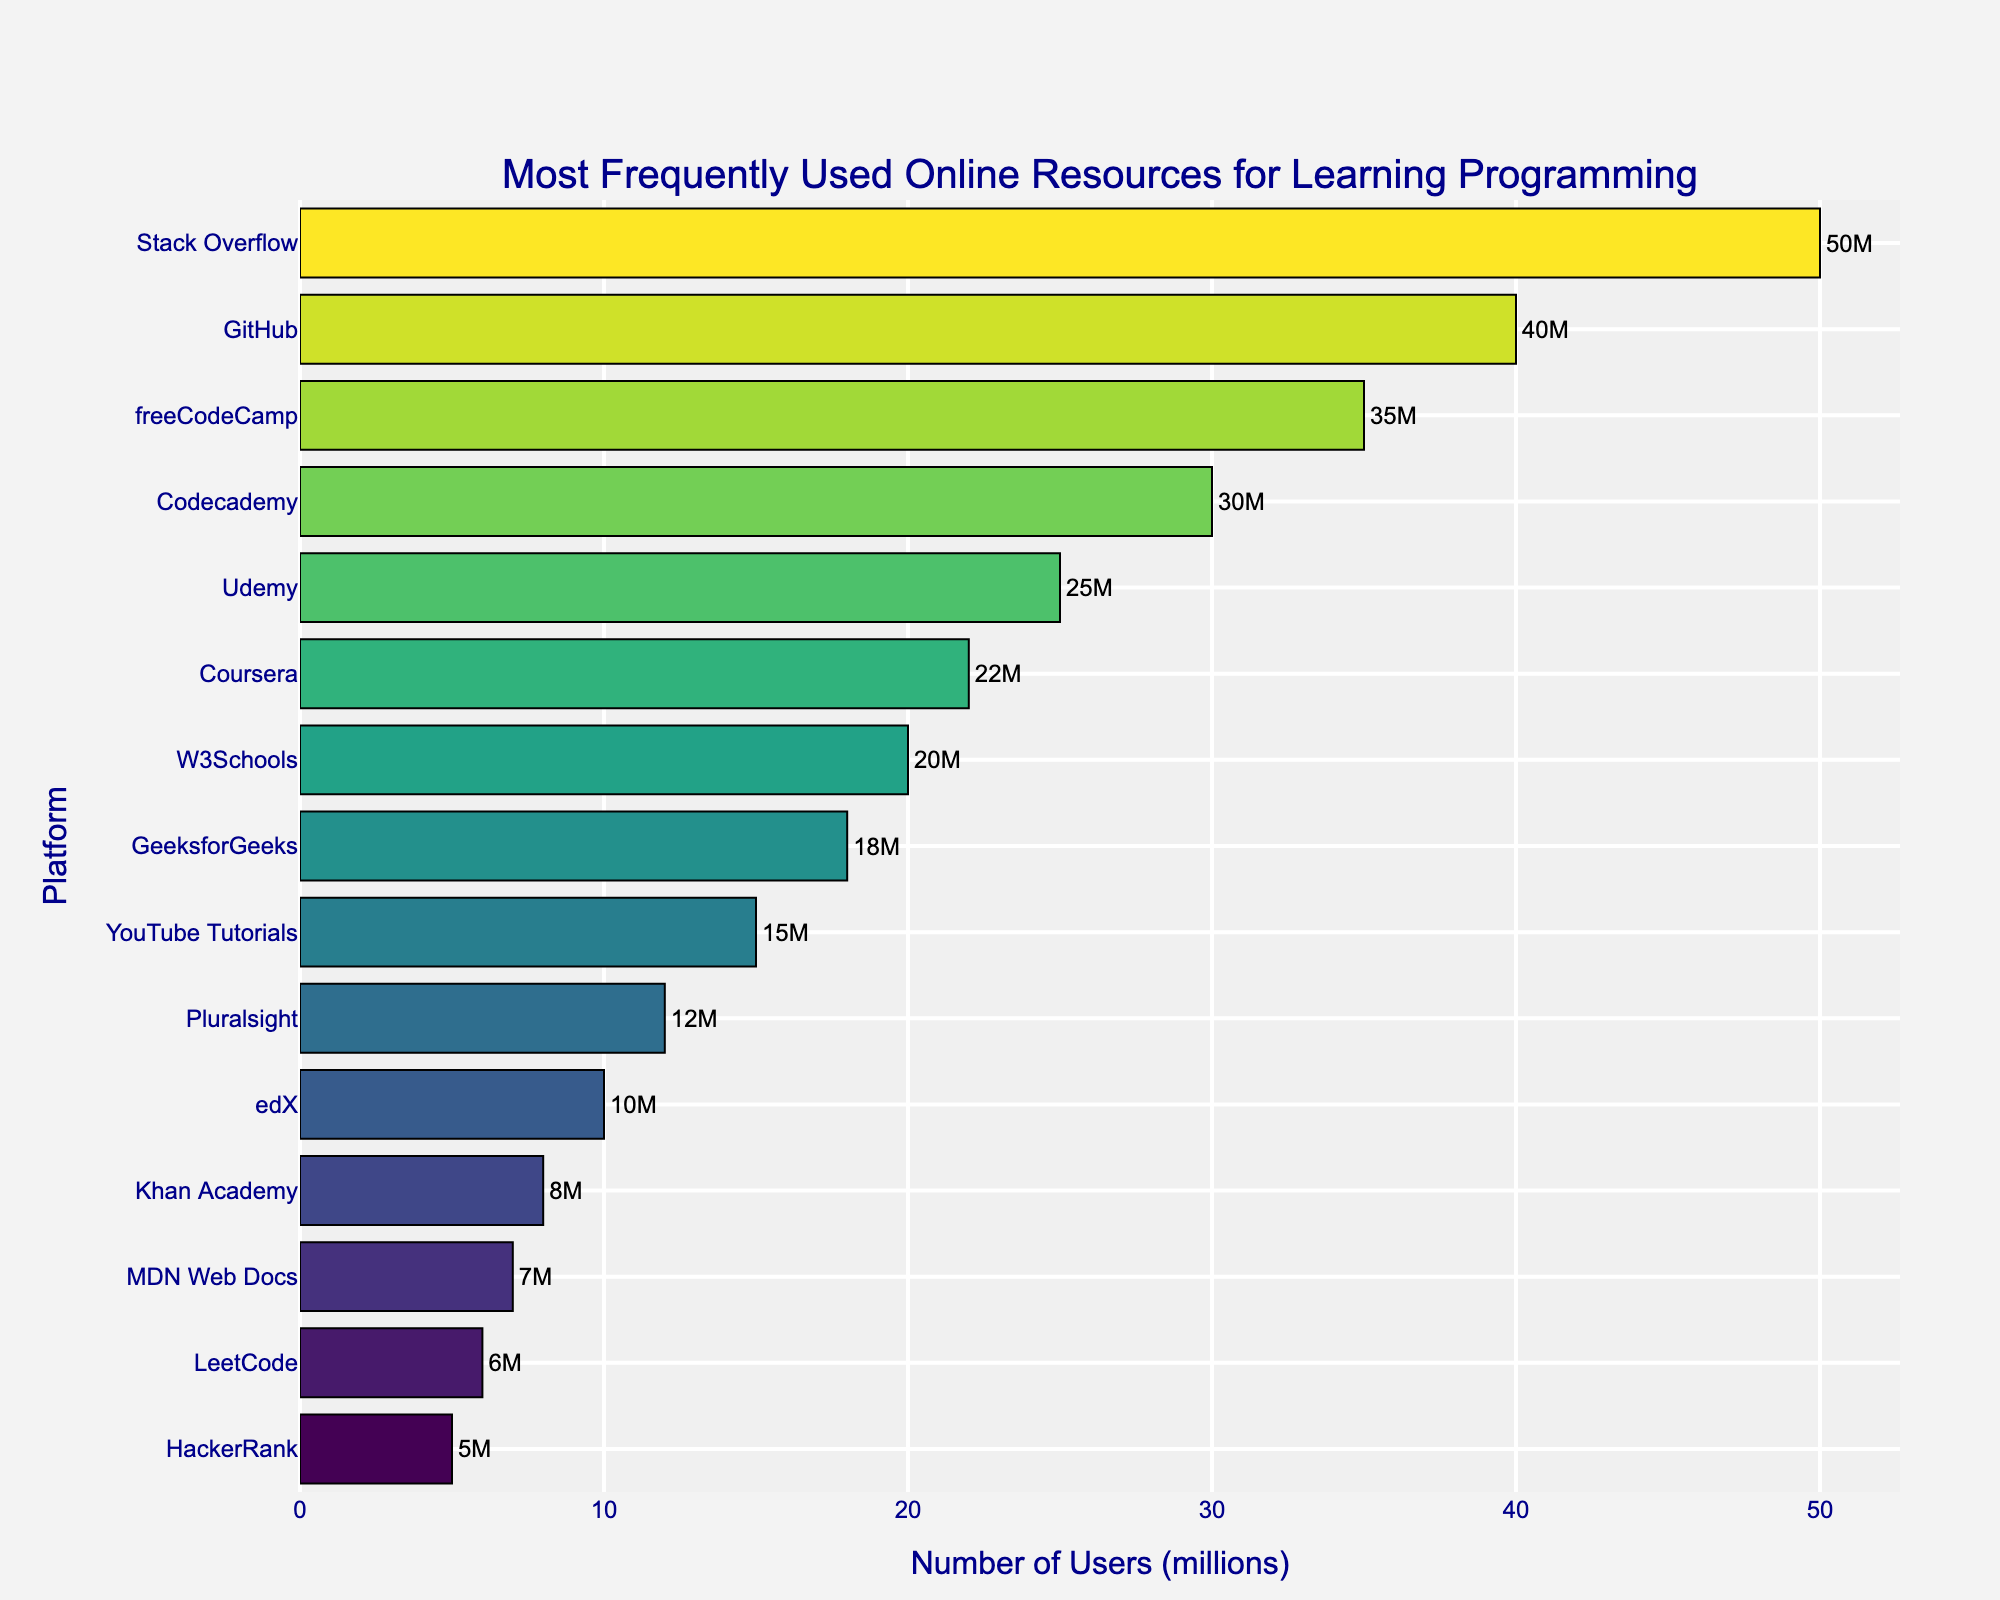Which platform has the most users? Stack Overflow is the platform with the most users mentioned in the chart, with 50 million users.
Answer: Stack Overflow Which platform has the least users? HackerRank has the least users mentioned in the chart, with 5 million users.
Answer: HackerRank How many more users does Stack Overflow have than YouTube Tutorials? Stack Overflow has 50 million users and YouTube Tutorials has 15 million users. The difference is 50 - 15 = 35 million users.
Answer: 35 million Which two platforms have the closest number of users? Coursera has 22 million users, and W3Schools has 20 million users, making the difference only 2 million users.
Answer: Coursera and W3Schools What is the median number of users across all platforms? To find the median, list all the numbers in ascending order: 5, 6, 7, 8, 10, 12, 15, 18, 20, 22, 25, 30, 35, 40, 50. The middle value is the 8th number, which is 18.
Answer: 18 How many platforms have more than 30 million users? The platforms with more than 30 million users are Stack Overflow (50), GitHub (40), freeCodeCamp (35), and Codecademy (30).
Answer: 4 What is the total number of users for GitHub and Codecademy combined? GitHub has 40 million users and Codecademy has 30 million users. Combined, they have 40 + 30 = 70 million users.
Answer: 70 million Which platform has a little over half the users compared to Stack Overflow? GitHub has 40 million users, which is a little over half of Stack Overflow's 50 million users.
Answer: GitHub What is the average number of users across all platforms? Sum of all users: 50 + 40 + 35 + 30 + 25 + 22 + 20 + 18 + 15 + 12 + 10 + 8 + 7 + 6 + 5 = 303 million. There are 15 platforms, so the average is 303 / 15 = 20.2 million users.
Answer: 20.2 million How does the number of users for Coursera compare to Udemy? Udemy has 25 million users, and Coursera has 22 million users. So, Coursera has 3 million fewer users than Udemy.
Answer: 3 million fewer 